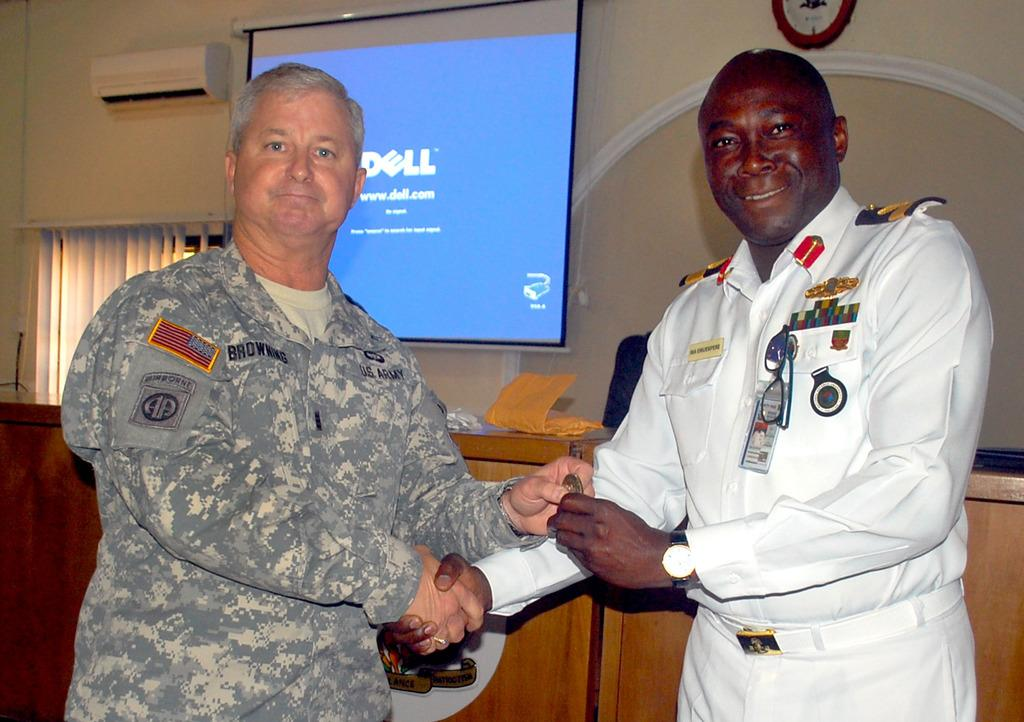<image>
Write a terse but informative summary of the picture. two men shaking hands with a Dell slide in the background 